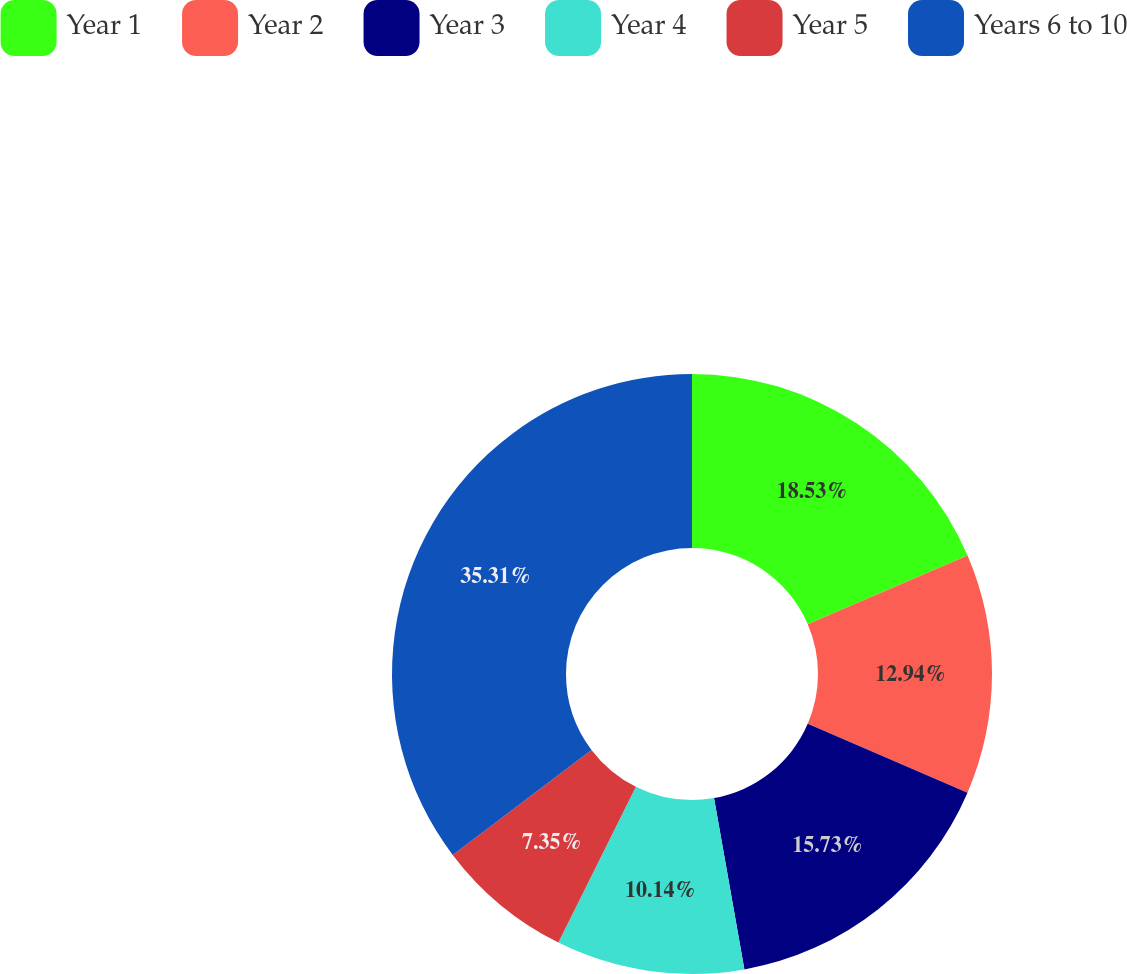<chart> <loc_0><loc_0><loc_500><loc_500><pie_chart><fcel>Year 1<fcel>Year 2<fcel>Year 3<fcel>Year 4<fcel>Year 5<fcel>Years 6 to 10<nl><fcel>18.53%<fcel>12.94%<fcel>15.73%<fcel>10.14%<fcel>7.35%<fcel>35.3%<nl></chart> 